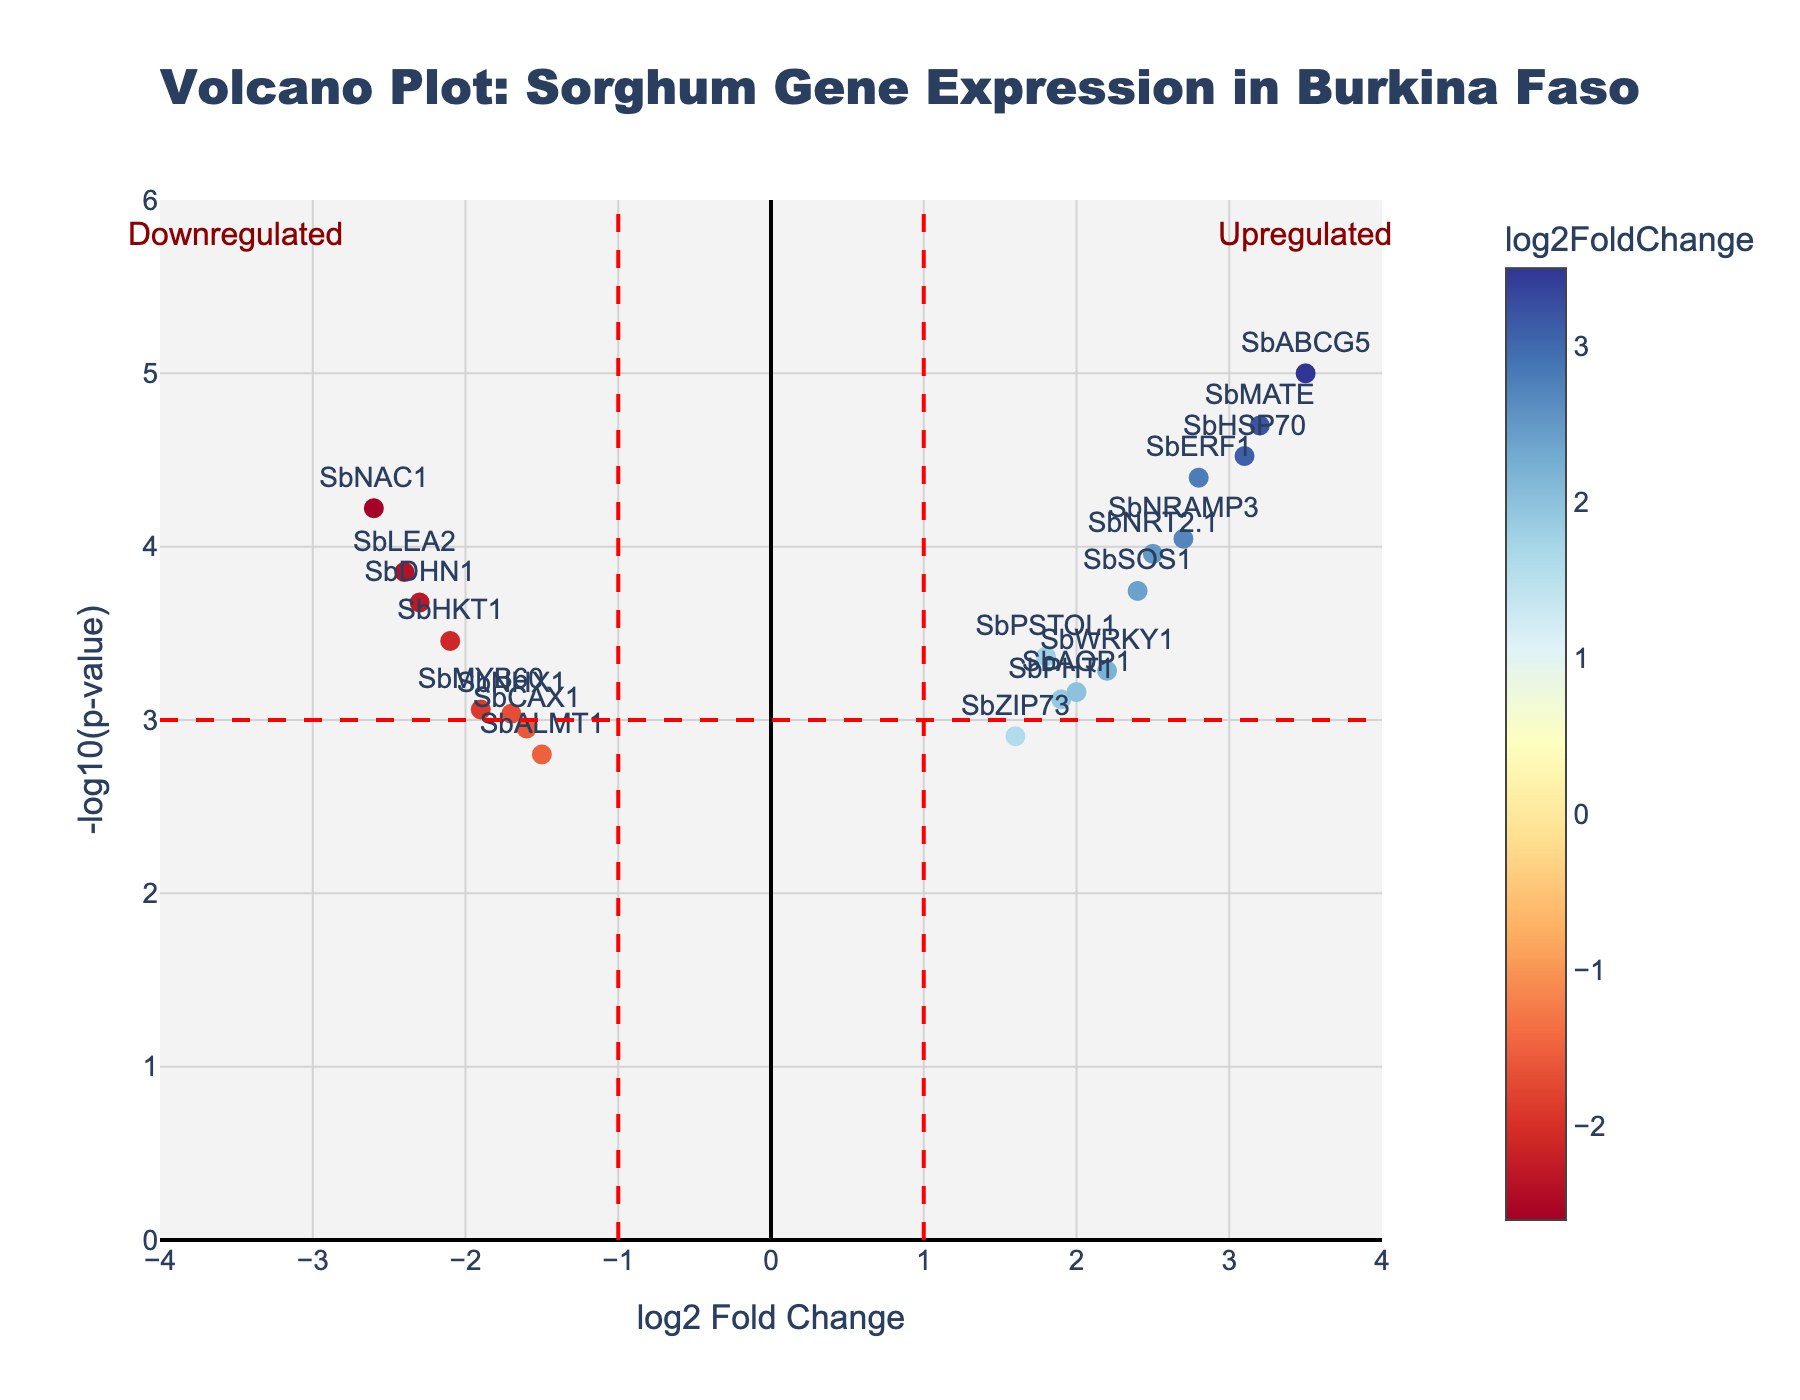How many genes are represented in the plot? Count the number of gene labels in the plot.
Answer: 20 What are the axes titles in the volcano plot? Examine the uploaded axes titles; the x-axis represents the log2 Fold Change, and the y-axis represents the -log10(p-value).
Answer: log2 Fold Change and -log10(p-value) Which gene has the highest -log10(p-value)? Look for the data point with the highest y-value, which corresponds to the smallest p-value. In this plot, it’s SbABCG5.
Answer: SbABCG5 Between SbDHN1 and SbMATE, which has a greater magnitude of log2FoldChange? Compare the absolute values of log2FoldChange for both genes. SbDHN1 = -2.3 and SbMATE = 3.2. SbMATE has a higher magnitude.
Answer: SbMATE How many genes are considered significantly upregulated? Count the number of genes where log2FoldChange > 1 and -log10(pvalue) > 3. These are the points lying to the far right above the horizontal red dashed line. In this plot, there are six such genes.
Answer: 6 Which gene shows the highest log2FoldChange? Identify the data point with the highest x-value (log2FoldChange). In this plot, it’s SbABCG5.
Answer: SbABCG5 What is the color scale used for the points in the volcano plot? The legend indicates that colors correspond to log2FoldChange values. The colors transition according to a red-yellow-blue (RdYlBu) color scale.
Answer: RdYlBu What is the general trend observed between the log2FoldChange and p-value of the differentially expressed genes? Typically, the most significant genes (-log10(pvalue) > 3) are located at higher absolute values of log2FoldChange, indicating that more extreme changes in expression tend to have lower p-values.
Answer: Extreme changes in expression have lower p-values How are the upregulated and downregulated genes visually distinguished in this plot? Upregulated genes have positive log2FoldChange and tend to be on the right, while downregulated genes have negative log2FoldChange and tend to be on the left. Additionally, the plot labels "Upregulated" on the right side and "Downregulated" on the left side.
Answer: Right for upregulated, left for downregulated 